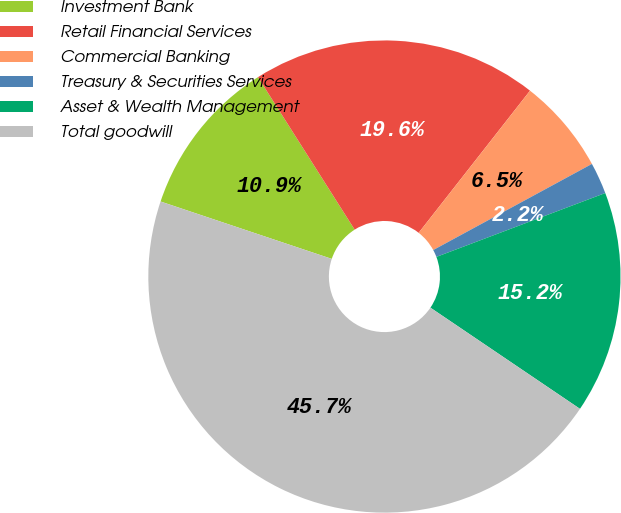Convert chart. <chart><loc_0><loc_0><loc_500><loc_500><pie_chart><fcel>Investment Bank<fcel>Retail Financial Services<fcel>Commercial Banking<fcel>Treasury & Securities Services<fcel>Asset & Wealth Management<fcel>Total goodwill<nl><fcel>10.86%<fcel>19.57%<fcel>6.51%<fcel>2.16%<fcel>15.22%<fcel>45.68%<nl></chart> 